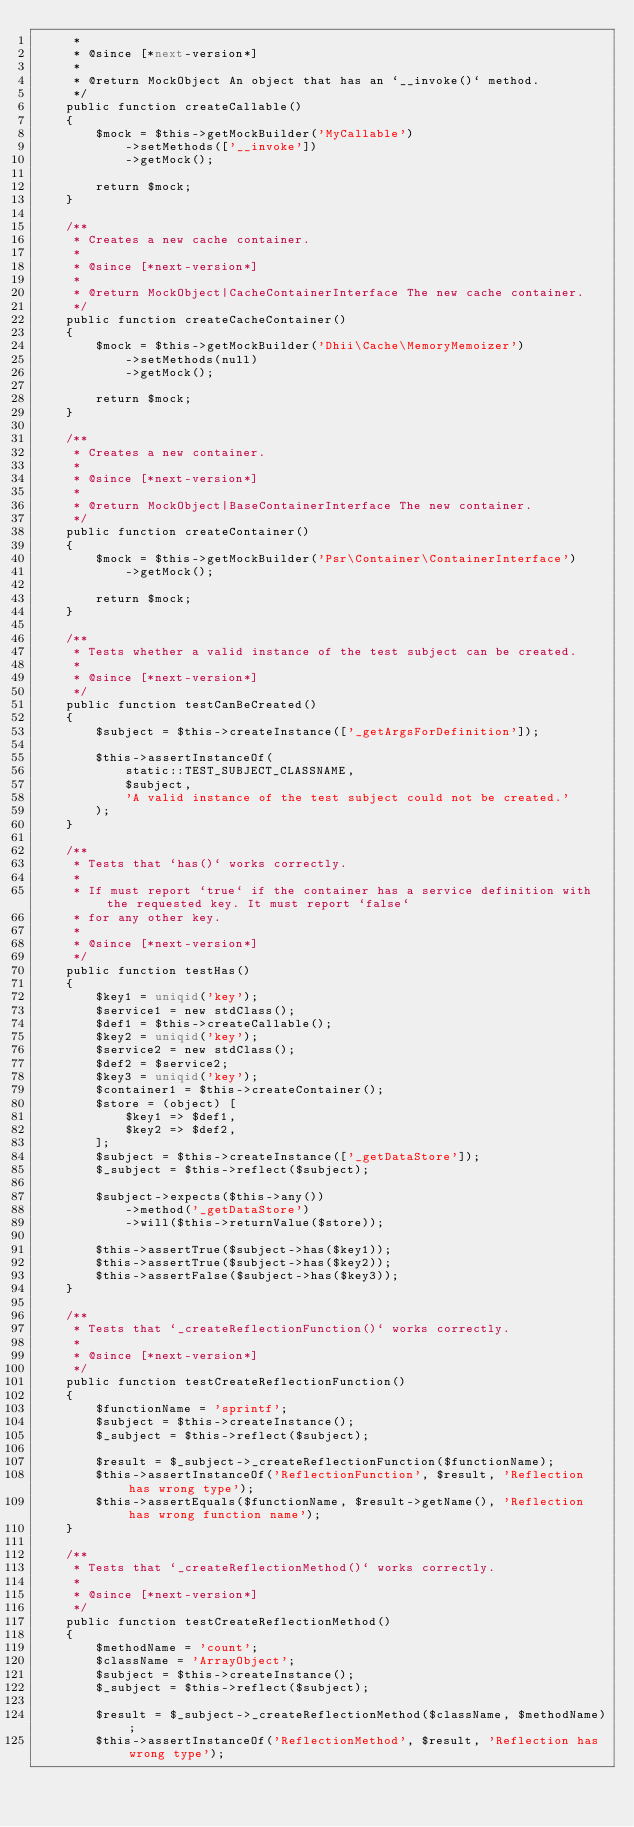<code> <loc_0><loc_0><loc_500><loc_500><_PHP_>     *
     * @since [*next-version*]
     *
     * @return MockObject An object that has an `__invoke()` method.
     */
    public function createCallable()
    {
        $mock = $this->getMockBuilder('MyCallable')
            ->setMethods(['__invoke'])
            ->getMock();

        return $mock;
    }

    /**
     * Creates a new cache container.
     *
     * @since [*next-version*]
     *
     * @return MockObject|CacheContainerInterface The new cache container.
     */
    public function createCacheContainer()
    {
        $mock = $this->getMockBuilder('Dhii\Cache\MemoryMemoizer')
            ->setMethods(null)
            ->getMock();

        return $mock;
    }

    /**
     * Creates a new container.
     *
     * @since [*next-version*]
     *
     * @return MockObject|BaseContainerInterface The new container.
     */
    public function createContainer()
    {
        $mock = $this->getMockBuilder('Psr\Container\ContainerInterface')
            ->getMock();

        return $mock;
    }

    /**
     * Tests whether a valid instance of the test subject can be created.
     *
     * @since [*next-version*]
     */
    public function testCanBeCreated()
    {
        $subject = $this->createInstance(['_getArgsForDefinition']);

        $this->assertInstanceOf(
            static::TEST_SUBJECT_CLASSNAME,
            $subject,
            'A valid instance of the test subject could not be created.'
        );
    }

    /**
     * Tests that `has()` works correctly.
     *
     * If must report `true` if the container has a service definition with the requested key. It must report `false`
     * for any other key.
     *
     * @since [*next-version*]
     */
    public function testHas()
    {
        $key1 = uniqid('key');
        $service1 = new stdClass();
        $def1 = $this->createCallable();
        $key2 = uniqid('key');
        $service2 = new stdClass();
        $def2 = $service2;
        $key3 = uniqid('key');
        $container1 = $this->createContainer();
        $store = (object) [
            $key1 => $def1,
            $key2 => $def2,
        ];
        $subject = $this->createInstance(['_getDataStore']);
        $_subject = $this->reflect($subject);

        $subject->expects($this->any())
            ->method('_getDataStore')
            ->will($this->returnValue($store));

        $this->assertTrue($subject->has($key1));
        $this->assertTrue($subject->has($key2));
        $this->assertFalse($subject->has($key3));
    }

    /**
     * Tests that `_createReflectionFunction()` works correctly.
     *
     * @since [*next-version*]
     */
    public function testCreateReflectionFunction()
    {
        $functionName = 'sprintf';
        $subject = $this->createInstance();
        $_subject = $this->reflect($subject);

        $result = $_subject->_createReflectionFunction($functionName);
        $this->assertInstanceOf('ReflectionFunction', $result, 'Reflection has wrong type');
        $this->assertEquals($functionName, $result->getName(), 'Reflection has wrong function name');
    }

    /**
     * Tests that `_createReflectionMethod()` works correctly.
     *
     * @since [*next-version*]
     */
    public function testCreateReflectionMethod()
    {
        $methodName = 'count';
        $className = 'ArrayObject';
        $subject = $this->createInstance();
        $_subject = $this->reflect($subject);

        $result = $_subject->_createReflectionMethod($className, $methodName);
        $this->assertInstanceOf('ReflectionMethod', $result, 'Reflection has wrong type');</code> 